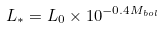<formula> <loc_0><loc_0><loc_500><loc_500>L _ { * } = L _ { 0 } \times 1 0 ^ { - 0 . 4 M _ { b o l } }</formula> 